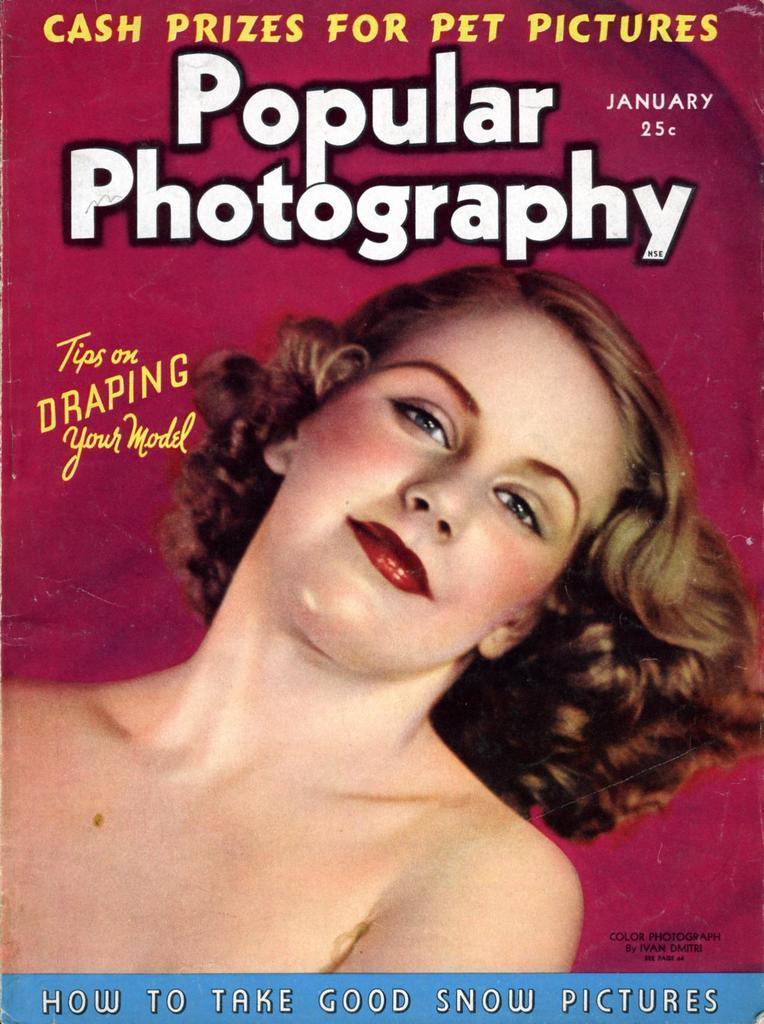Please provide a concise description of this image. In this image we can see the picture of a woman. We can also see some text on this image. 